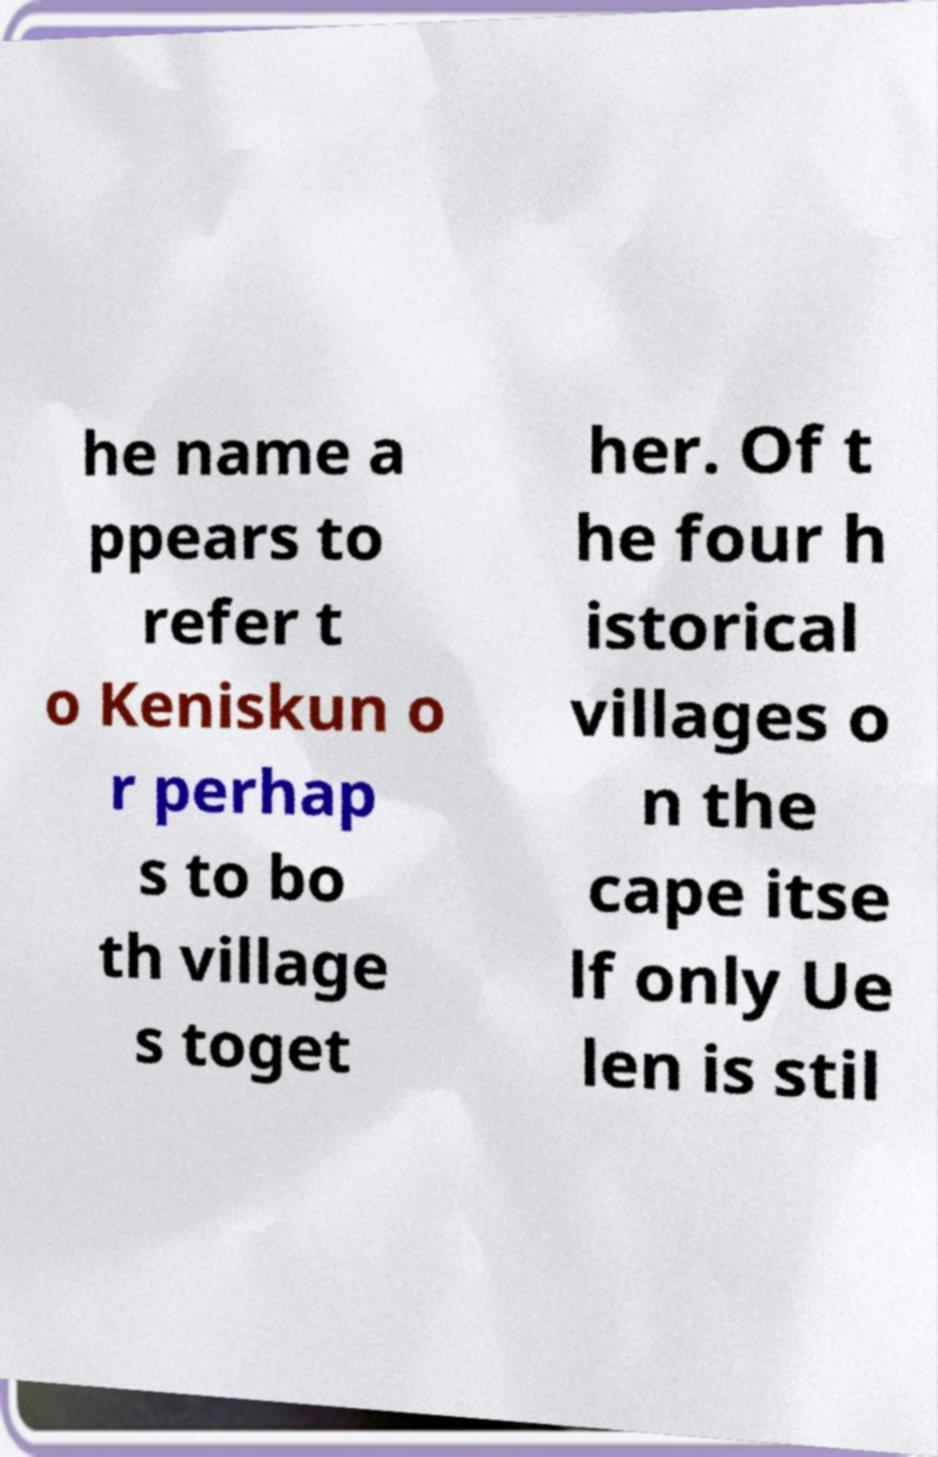Please read and relay the text visible in this image. What does it say? he name a ppears to refer t o Keniskun o r perhap s to bo th village s toget her. Of t he four h istorical villages o n the cape itse lf only Ue len is stil 